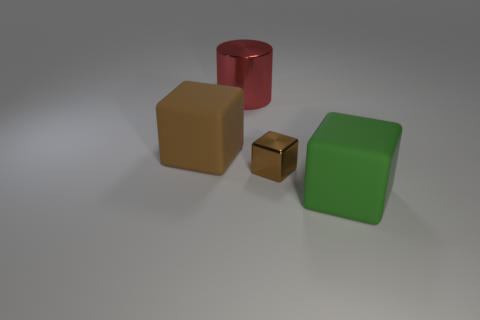What number of cylinders are in front of the tiny brown metal cube that is behind the object right of the tiny object?
Ensure brevity in your answer.  0. What is the size of the matte object that is the same color as the small block?
Offer a very short reply. Large. There is a large red thing; what shape is it?
Offer a very short reply. Cylinder. How many tiny yellow spheres have the same material as the large green block?
Your answer should be compact. 0. What color is the cube that is made of the same material as the big green object?
Make the answer very short. Brown. Does the red cylinder have the same size as the matte cube in front of the large brown thing?
Offer a very short reply. Yes. What is the material of the cube right of the metallic cube to the right of the metal thing behind the brown matte object?
Ensure brevity in your answer.  Rubber. What number of objects are large red shiny cylinders or large brown matte things?
Your response must be concise. 2. Do the shiny thing in front of the big brown rubber thing and the matte object that is left of the large cylinder have the same color?
Provide a short and direct response. Yes. What shape is the metallic thing that is the same size as the brown rubber thing?
Offer a terse response. Cylinder. 